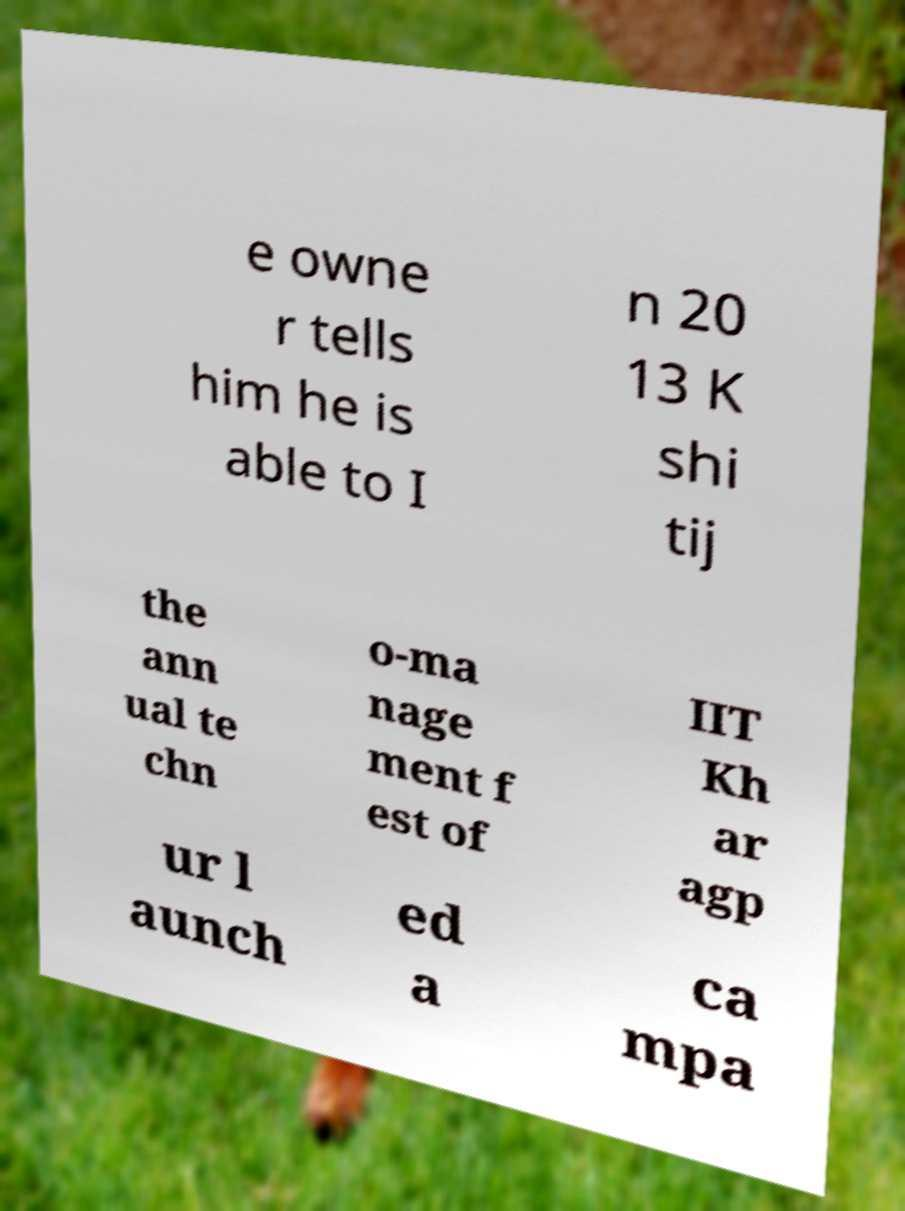What messages or text are displayed in this image? I need them in a readable, typed format. e owne r tells him he is able to I n 20 13 K shi tij the ann ual te chn o-ma nage ment f est of IIT Kh ar agp ur l aunch ed a ca mpa 